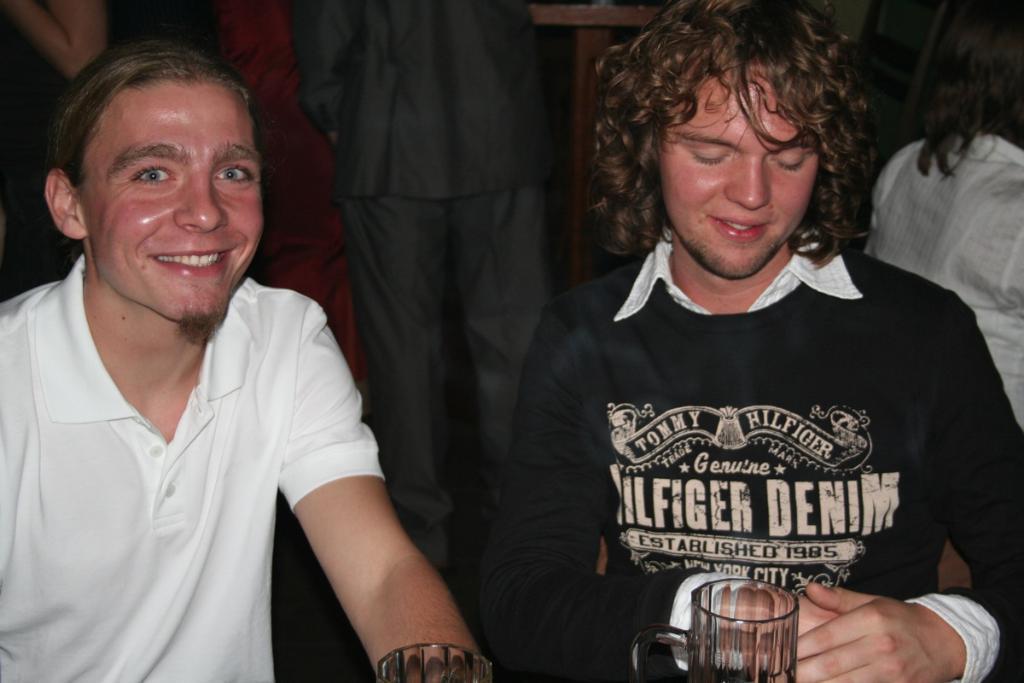Describe this image in one or two sentences. In this picture we can observe two men. One of them is wearing a white color t-shirt and the other is wearing black color t-shirt. Both of them are smiling. There are glasses in front of them. In the background there are some people. 